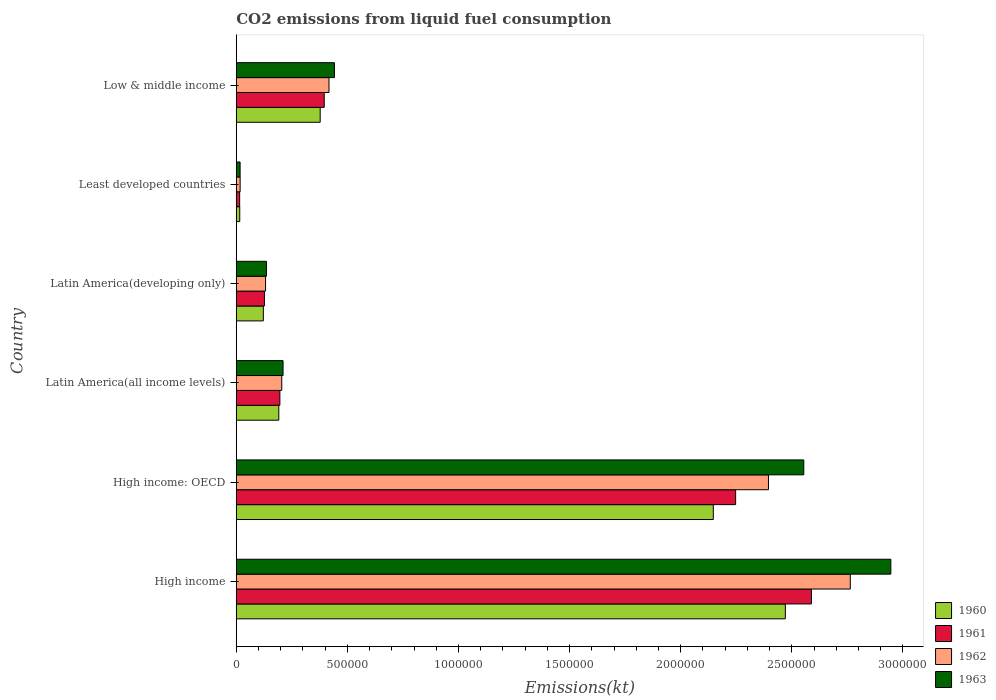How many different coloured bars are there?
Ensure brevity in your answer.  4. Are the number of bars on each tick of the Y-axis equal?
Make the answer very short. Yes. How many bars are there on the 4th tick from the top?
Keep it short and to the point. 4. What is the label of the 3rd group of bars from the top?
Give a very brief answer. Latin America(developing only). What is the amount of CO2 emitted in 1962 in High income?
Your answer should be very brief. 2.76e+06. Across all countries, what is the maximum amount of CO2 emitted in 1963?
Offer a very short reply. 2.95e+06. Across all countries, what is the minimum amount of CO2 emitted in 1960?
Provide a succinct answer. 1.57e+04. In which country was the amount of CO2 emitted in 1961 maximum?
Provide a short and direct response. High income. In which country was the amount of CO2 emitted in 1963 minimum?
Your answer should be very brief. Least developed countries. What is the total amount of CO2 emitted in 1961 in the graph?
Keep it short and to the point. 5.57e+06. What is the difference between the amount of CO2 emitted in 1962 in High income and that in Latin America(all income levels)?
Your answer should be very brief. 2.56e+06. What is the difference between the amount of CO2 emitted in 1962 in Latin America(all income levels) and the amount of CO2 emitted in 1961 in Latin America(developing only)?
Offer a terse response. 7.79e+04. What is the average amount of CO2 emitted in 1960 per country?
Keep it short and to the point. 8.87e+05. What is the difference between the amount of CO2 emitted in 1963 and amount of CO2 emitted in 1960 in Least developed countries?
Offer a terse response. 1527.9. What is the ratio of the amount of CO2 emitted in 1962 in Latin America(all income levels) to that in Least developed countries?
Offer a terse response. 11.72. Is the difference between the amount of CO2 emitted in 1963 in High income: OECD and Low & middle income greater than the difference between the amount of CO2 emitted in 1960 in High income: OECD and Low & middle income?
Provide a succinct answer. Yes. What is the difference between the highest and the second highest amount of CO2 emitted in 1961?
Keep it short and to the point. 3.41e+05. What is the difference between the highest and the lowest amount of CO2 emitted in 1963?
Your answer should be very brief. 2.93e+06. Is the sum of the amount of CO2 emitted in 1960 in High income: OECD and Low & middle income greater than the maximum amount of CO2 emitted in 1962 across all countries?
Ensure brevity in your answer.  No. What does the 1st bar from the bottom in Low & middle income represents?
Give a very brief answer. 1960. How many bars are there?
Keep it short and to the point. 24. Are the values on the major ticks of X-axis written in scientific E-notation?
Offer a very short reply. No. Does the graph contain grids?
Provide a short and direct response. No. Where does the legend appear in the graph?
Make the answer very short. Bottom right. How many legend labels are there?
Your answer should be compact. 4. How are the legend labels stacked?
Offer a very short reply. Vertical. What is the title of the graph?
Keep it short and to the point. CO2 emissions from liquid fuel consumption. What is the label or title of the X-axis?
Make the answer very short. Emissions(kt). What is the Emissions(kt) of 1960 in High income?
Make the answer very short. 2.47e+06. What is the Emissions(kt) of 1961 in High income?
Provide a short and direct response. 2.59e+06. What is the Emissions(kt) in 1962 in High income?
Your response must be concise. 2.76e+06. What is the Emissions(kt) in 1963 in High income?
Your answer should be very brief. 2.95e+06. What is the Emissions(kt) in 1960 in High income: OECD?
Your response must be concise. 2.15e+06. What is the Emissions(kt) of 1961 in High income: OECD?
Give a very brief answer. 2.25e+06. What is the Emissions(kt) of 1962 in High income: OECD?
Offer a very short reply. 2.39e+06. What is the Emissions(kt) in 1963 in High income: OECD?
Make the answer very short. 2.55e+06. What is the Emissions(kt) of 1960 in Latin America(all income levels)?
Ensure brevity in your answer.  1.91e+05. What is the Emissions(kt) in 1961 in Latin America(all income levels)?
Offer a very short reply. 1.96e+05. What is the Emissions(kt) of 1962 in Latin America(all income levels)?
Provide a short and direct response. 2.05e+05. What is the Emissions(kt) of 1963 in Latin America(all income levels)?
Your answer should be very brief. 2.11e+05. What is the Emissions(kt) in 1960 in Latin America(developing only)?
Make the answer very short. 1.22e+05. What is the Emissions(kt) in 1961 in Latin America(developing only)?
Your answer should be compact. 1.27e+05. What is the Emissions(kt) of 1962 in Latin America(developing only)?
Keep it short and to the point. 1.32e+05. What is the Emissions(kt) in 1963 in Latin America(developing only)?
Give a very brief answer. 1.36e+05. What is the Emissions(kt) of 1960 in Least developed countries?
Offer a terse response. 1.57e+04. What is the Emissions(kt) in 1961 in Least developed countries?
Your response must be concise. 1.53e+04. What is the Emissions(kt) in 1962 in Least developed countries?
Provide a short and direct response. 1.75e+04. What is the Emissions(kt) in 1963 in Least developed countries?
Provide a short and direct response. 1.73e+04. What is the Emissions(kt) in 1960 in Low & middle income?
Make the answer very short. 3.78e+05. What is the Emissions(kt) in 1961 in Low & middle income?
Ensure brevity in your answer.  3.96e+05. What is the Emissions(kt) in 1962 in Low & middle income?
Make the answer very short. 4.17e+05. What is the Emissions(kt) of 1963 in Low & middle income?
Provide a short and direct response. 4.42e+05. Across all countries, what is the maximum Emissions(kt) of 1960?
Your answer should be very brief. 2.47e+06. Across all countries, what is the maximum Emissions(kt) in 1961?
Offer a very short reply. 2.59e+06. Across all countries, what is the maximum Emissions(kt) of 1962?
Your response must be concise. 2.76e+06. Across all countries, what is the maximum Emissions(kt) in 1963?
Your answer should be very brief. 2.95e+06. Across all countries, what is the minimum Emissions(kt) of 1960?
Give a very brief answer. 1.57e+04. Across all countries, what is the minimum Emissions(kt) in 1961?
Give a very brief answer. 1.53e+04. Across all countries, what is the minimum Emissions(kt) in 1962?
Provide a succinct answer. 1.75e+04. Across all countries, what is the minimum Emissions(kt) in 1963?
Provide a succinct answer. 1.73e+04. What is the total Emissions(kt) in 1960 in the graph?
Provide a short and direct response. 5.32e+06. What is the total Emissions(kt) of 1961 in the graph?
Your response must be concise. 5.57e+06. What is the total Emissions(kt) of 1962 in the graph?
Keep it short and to the point. 5.93e+06. What is the total Emissions(kt) in 1963 in the graph?
Offer a terse response. 6.30e+06. What is the difference between the Emissions(kt) in 1960 in High income and that in High income: OECD?
Your response must be concise. 3.24e+05. What is the difference between the Emissions(kt) of 1961 in High income and that in High income: OECD?
Provide a succinct answer. 3.41e+05. What is the difference between the Emissions(kt) in 1962 in High income and that in High income: OECD?
Offer a very short reply. 3.68e+05. What is the difference between the Emissions(kt) of 1963 in High income and that in High income: OECD?
Provide a succinct answer. 3.92e+05. What is the difference between the Emissions(kt) in 1960 in High income and that in Latin America(all income levels)?
Provide a short and direct response. 2.28e+06. What is the difference between the Emissions(kt) in 1961 in High income and that in Latin America(all income levels)?
Provide a succinct answer. 2.39e+06. What is the difference between the Emissions(kt) of 1962 in High income and that in Latin America(all income levels)?
Your answer should be compact. 2.56e+06. What is the difference between the Emissions(kt) of 1963 in High income and that in Latin America(all income levels)?
Ensure brevity in your answer.  2.73e+06. What is the difference between the Emissions(kt) of 1960 in High income and that in Latin America(developing only)?
Keep it short and to the point. 2.35e+06. What is the difference between the Emissions(kt) of 1961 in High income and that in Latin America(developing only)?
Offer a very short reply. 2.46e+06. What is the difference between the Emissions(kt) of 1962 in High income and that in Latin America(developing only)?
Give a very brief answer. 2.63e+06. What is the difference between the Emissions(kt) of 1963 in High income and that in Latin America(developing only)?
Give a very brief answer. 2.81e+06. What is the difference between the Emissions(kt) of 1960 in High income and that in Least developed countries?
Keep it short and to the point. 2.46e+06. What is the difference between the Emissions(kt) of 1961 in High income and that in Least developed countries?
Make the answer very short. 2.57e+06. What is the difference between the Emissions(kt) in 1962 in High income and that in Least developed countries?
Offer a very short reply. 2.75e+06. What is the difference between the Emissions(kt) in 1963 in High income and that in Least developed countries?
Give a very brief answer. 2.93e+06. What is the difference between the Emissions(kt) of 1960 in High income and that in Low & middle income?
Provide a short and direct response. 2.09e+06. What is the difference between the Emissions(kt) in 1961 in High income and that in Low & middle income?
Give a very brief answer. 2.19e+06. What is the difference between the Emissions(kt) in 1962 in High income and that in Low & middle income?
Offer a very short reply. 2.35e+06. What is the difference between the Emissions(kt) in 1963 in High income and that in Low & middle income?
Keep it short and to the point. 2.50e+06. What is the difference between the Emissions(kt) in 1960 in High income: OECD and that in Latin America(all income levels)?
Give a very brief answer. 1.96e+06. What is the difference between the Emissions(kt) in 1961 in High income: OECD and that in Latin America(all income levels)?
Keep it short and to the point. 2.05e+06. What is the difference between the Emissions(kt) of 1962 in High income: OECD and that in Latin America(all income levels)?
Your answer should be compact. 2.19e+06. What is the difference between the Emissions(kt) in 1963 in High income: OECD and that in Latin America(all income levels)?
Your answer should be very brief. 2.34e+06. What is the difference between the Emissions(kt) in 1960 in High income: OECD and that in Latin America(developing only)?
Your answer should be very brief. 2.02e+06. What is the difference between the Emissions(kt) of 1961 in High income: OECD and that in Latin America(developing only)?
Keep it short and to the point. 2.12e+06. What is the difference between the Emissions(kt) in 1962 in High income: OECD and that in Latin America(developing only)?
Offer a very short reply. 2.26e+06. What is the difference between the Emissions(kt) in 1963 in High income: OECD and that in Latin America(developing only)?
Your answer should be compact. 2.42e+06. What is the difference between the Emissions(kt) of 1960 in High income: OECD and that in Least developed countries?
Your response must be concise. 2.13e+06. What is the difference between the Emissions(kt) of 1961 in High income: OECD and that in Least developed countries?
Your answer should be very brief. 2.23e+06. What is the difference between the Emissions(kt) in 1962 in High income: OECD and that in Least developed countries?
Ensure brevity in your answer.  2.38e+06. What is the difference between the Emissions(kt) of 1963 in High income: OECD and that in Least developed countries?
Your answer should be compact. 2.54e+06. What is the difference between the Emissions(kt) of 1960 in High income: OECD and that in Low & middle income?
Your response must be concise. 1.77e+06. What is the difference between the Emissions(kt) in 1961 in High income: OECD and that in Low & middle income?
Ensure brevity in your answer.  1.85e+06. What is the difference between the Emissions(kt) in 1962 in High income: OECD and that in Low & middle income?
Your response must be concise. 1.98e+06. What is the difference between the Emissions(kt) of 1963 in High income: OECD and that in Low & middle income?
Ensure brevity in your answer.  2.11e+06. What is the difference between the Emissions(kt) of 1960 in Latin America(all income levels) and that in Latin America(developing only)?
Provide a short and direct response. 6.96e+04. What is the difference between the Emissions(kt) of 1961 in Latin America(all income levels) and that in Latin America(developing only)?
Provide a succinct answer. 6.94e+04. What is the difference between the Emissions(kt) in 1962 in Latin America(all income levels) and that in Latin America(developing only)?
Give a very brief answer. 7.28e+04. What is the difference between the Emissions(kt) in 1963 in Latin America(all income levels) and that in Latin America(developing only)?
Your answer should be compact. 7.46e+04. What is the difference between the Emissions(kt) in 1960 in Latin America(all income levels) and that in Least developed countries?
Ensure brevity in your answer.  1.76e+05. What is the difference between the Emissions(kt) in 1961 in Latin America(all income levels) and that in Least developed countries?
Give a very brief answer. 1.81e+05. What is the difference between the Emissions(kt) in 1962 in Latin America(all income levels) and that in Least developed countries?
Provide a succinct answer. 1.87e+05. What is the difference between the Emissions(kt) in 1963 in Latin America(all income levels) and that in Least developed countries?
Keep it short and to the point. 1.93e+05. What is the difference between the Emissions(kt) in 1960 in Latin America(all income levels) and that in Low & middle income?
Your response must be concise. -1.86e+05. What is the difference between the Emissions(kt) in 1961 in Latin America(all income levels) and that in Low & middle income?
Your answer should be compact. -2.00e+05. What is the difference between the Emissions(kt) of 1962 in Latin America(all income levels) and that in Low & middle income?
Provide a succinct answer. -2.13e+05. What is the difference between the Emissions(kt) of 1963 in Latin America(all income levels) and that in Low & middle income?
Offer a terse response. -2.31e+05. What is the difference between the Emissions(kt) in 1960 in Latin America(developing only) and that in Least developed countries?
Make the answer very short. 1.06e+05. What is the difference between the Emissions(kt) in 1961 in Latin America(developing only) and that in Least developed countries?
Make the answer very short. 1.11e+05. What is the difference between the Emissions(kt) of 1962 in Latin America(developing only) and that in Least developed countries?
Your response must be concise. 1.14e+05. What is the difference between the Emissions(kt) in 1963 in Latin America(developing only) and that in Least developed countries?
Your answer should be very brief. 1.19e+05. What is the difference between the Emissions(kt) of 1960 in Latin America(developing only) and that in Low & middle income?
Keep it short and to the point. -2.56e+05. What is the difference between the Emissions(kt) in 1961 in Latin America(developing only) and that in Low & middle income?
Give a very brief answer. -2.69e+05. What is the difference between the Emissions(kt) of 1962 in Latin America(developing only) and that in Low & middle income?
Give a very brief answer. -2.85e+05. What is the difference between the Emissions(kt) in 1963 in Latin America(developing only) and that in Low & middle income?
Ensure brevity in your answer.  -3.06e+05. What is the difference between the Emissions(kt) in 1960 in Least developed countries and that in Low & middle income?
Keep it short and to the point. -3.62e+05. What is the difference between the Emissions(kt) of 1961 in Least developed countries and that in Low & middle income?
Keep it short and to the point. -3.81e+05. What is the difference between the Emissions(kt) in 1962 in Least developed countries and that in Low & middle income?
Your response must be concise. -4.00e+05. What is the difference between the Emissions(kt) in 1963 in Least developed countries and that in Low & middle income?
Provide a short and direct response. -4.25e+05. What is the difference between the Emissions(kt) in 1960 in High income and the Emissions(kt) in 1961 in High income: OECD?
Offer a very short reply. 2.24e+05. What is the difference between the Emissions(kt) in 1960 in High income and the Emissions(kt) in 1962 in High income: OECD?
Give a very brief answer. 7.59e+04. What is the difference between the Emissions(kt) of 1960 in High income and the Emissions(kt) of 1963 in High income: OECD?
Ensure brevity in your answer.  -8.29e+04. What is the difference between the Emissions(kt) of 1961 in High income and the Emissions(kt) of 1962 in High income: OECD?
Your answer should be very brief. 1.93e+05. What is the difference between the Emissions(kt) in 1961 in High income and the Emissions(kt) in 1963 in High income: OECD?
Make the answer very short. 3.45e+04. What is the difference between the Emissions(kt) of 1962 in High income and the Emissions(kt) of 1963 in High income: OECD?
Give a very brief answer. 2.09e+05. What is the difference between the Emissions(kt) of 1960 in High income and the Emissions(kt) of 1961 in Latin America(all income levels)?
Make the answer very short. 2.27e+06. What is the difference between the Emissions(kt) in 1960 in High income and the Emissions(kt) in 1962 in Latin America(all income levels)?
Provide a succinct answer. 2.27e+06. What is the difference between the Emissions(kt) in 1960 in High income and the Emissions(kt) in 1963 in Latin America(all income levels)?
Offer a terse response. 2.26e+06. What is the difference between the Emissions(kt) of 1961 in High income and the Emissions(kt) of 1962 in Latin America(all income levels)?
Your answer should be compact. 2.38e+06. What is the difference between the Emissions(kt) of 1961 in High income and the Emissions(kt) of 1963 in Latin America(all income levels)?
Your answer should be compact. 2.38e+06. What is the difference between the Emissions(kt) of 1962 in High income and the Emissions(kt) of 1963 in Latin America(all income levels)?
Give a very brief answer. 2.55e+06. What is the difference between the Emissions(kt) in 1960 in High income and the Emissions(kt) in 1961 in Latin America(developing only)?
Ensure brevity in your answer.  2.34e+06. What is the difference between the Emissions(kt) in 1960 in High income and the Emissions(kt) in 1962 in Latin America(developing only)?
Ensure brevity in your answer.  2.34e+06. What is the difference between the Emissions(kt) in 1960 in High income and the Emissions(kt) in 1963 in Latin America(developing only)?
Your answer should be very brief. 2.33e+06. What is the difference between the Emissions(kt) in 1961 in High income and the Emissions(kt) in 1962 in Latin America(developing only)?
Ensure brevity in your answer.  2.46e+06. What is the difference between the Emissions(kt) in 1961 in High income and the Emissions(kt) in 1963 in Latin America(developing only)?
Offer a terse response. 2.45e+06. What is the difference between the Emissions(kt) of 1962 in High income and the Emissions(kt) of 1963 in Latin America(developing only)?
Give a very brief answer. 2.63e+06. What is the difference between the Emissions(kt) in 1960 in High income and the Emissions(kt) in 1961 in Least developed countries?
Provide a short and direct response. 2.46e+06. What is the difference between the Emissions(kt) of 1960 in High income and the Emissions(kt) of 1962 in Least developed countries?
Your response must be concise. 2.45e+06. What is the difference between the Emissions(kt) of 1960 in High income and the Emissions(kt) of 1963 in Least developed countries?
Provide a succinct answer. 2.45e+06. What is the difference between the Emissions(kt) of 1961 in High income and the Emissions(kt) of 1962 in Least developed countries?
Ensure brevity in your answer.  2.57e+06. What is the difference between the Emissions(kt) in 1961 in High income and the Emissions(kt) in 1963 in Least developed countries?
Your answer should be very brief. 2.57e+06. What is the difference between the Emissions(kt) in 1962 in High income and the Emissions(kt) in 1963 in Least developed countries?
Give a very brief answer. 2.75e+06. What is the difference between the Emissions(kt) of 1960 in High income and the Emissions(kt) of 1961 in Low & middle income?
Offer a very short reply. 2.07e+06. What is the difference between the Emissions(kt) in 1960 in High income and the Emissions(kt) in 1962 in Low & middle income?
Your answer should be very brief. 2.05e+06. What is the difference between the Emissions(kt) of 1960 in High income and the Emissions(kt) of 1963 in Low & middle income?
Your answer should be very brief. 2.03e+06. What is the difference between the Emissions(kt) of 1961 in High income and the Emissions(kt) of 1962 in Low & middle income?
Keep it short and to the point. 2.17e+06. What is the difference between the Emissions(kt) in 1961 in High income and the Emissions(kt) in 1963 in Low & middle income?
Provide a succinct answer. 2.15e+06. What is the difference between the Emissions(kt) of 1962 in High income and the Emissions(kt) of 1963 in Low & middle income?
Your answer should be compact. 2.32e+06. What is the difference between the Emissions(kt) in 1960 in High income: OECD and the Emissions(kt) in 1961 in Latin America(all income levels)?
Provide a short and direct response. 1.95e+06. What is the difference between the Emissions(kt) in 1960 in High income: OECD and the Emissions(kt) in 1962 in Latin America(all income levels)?
Your answer should be compact. 1.94e+06. What is the difference between the Emissions(kt) of 1960 in High income: OECD and the Emissions(kt) of 1963 in Latin America(all income levels)?
Ensure brevity in your answer.  1.94e+06. What is the difference between the Emissions(kt) of 1961 in High income: OECD and the Emissions(kt) of 1962 in Latin America(all income levels)?
Your response must be concise. 2.04e+06. What is the difference between the Emissions(kt) of 1961 in High income: OECD and the Emissions(kt) of 1963 in Latin America(all income levels)?
Offer a terse response. 2.04e+06. What is the difference between the Emissions(kt) in 1962 in High income: OECD and the Emissions(kt) in 1963 in Latin America(all income levels)?
Offer a terse response. 2.18e+06. What is the difference between the Emissions(kt) in 1960 in High income: OECD and the Emissions(kt) in 1961 in Latin America(developing only)?
Your answer should be compact. 2.02e+06. What is the difference between the Emissions(kt) in 1960 in High income: OECD and the Emissions(kt) in 1962 in Latin America(developing only)?
Provide a succinct answer. 2.01e+06. What is the difference between the Emissions(kt) of 1960 in High income: OECD and the Emissions(kt) of 1963 in Latin America(developing only)?
Ensure brevity in your answer.  2.01e+06. What is the difference between the Emissions(kt) in 1961 in High income: OECD and the Emissions(kt) in 1962 in Latin America(developing only)?
Provide a short and direct response. 2.12e+06. What is the difference between the Emissions(kt) of 1961 in High income: OECD and the Emissions(kt) of 1963 in Latin America(developing only)?
Make the answer very short. 2.11e+06. What is the difference between the Emissions(kt) in 1962 in High income: OECD and the Emissions(kt) in 1963 in Latin America(developing only)?
Provide a succinct answer. 2.26e+06. What is the difference between the Emissions(kt) of 1960 in High income: OECD and the Emissions(kt) of 1961 in Least developed countries?
Offer a very short reply. 2.13e+06. What is the difference between the Emissions(kt) of 1960 in High income: OECD and the Emissions(kt) of 1962 in Least developed countries?
Provide a short and direct response. 2.13e+06. What is the difference between the Emissions(kt) in 1960 in High income: OECD and the Emissions(kt) in 1963 in Least developed countries?
Offer a terse response. 2.13e+06. What is the difference between the Emissions(kt) of 1961 in High income: OECD and the Emissions(kt) of 1962 in Least developed countries?
Offer a terse response. 2.23e+06. What is the difference between the Emissions(kt) in 1961 in High income: OECD and the Emissions(kt) in 1963 in Least developed countries?
Your response must be concise. 2.23e+06. What is the difference between the Emissions(kt) in 1962 in High income: OECD and the Emissions(kt) in 1963 in Least developed countries?
Provide a short and direct response. 2.38e+06. What is the difference between the Emissions(kt) of 1960 in High income: OECD and the Emissions(kt) of 1961 in Low & middle income?
Provide a short and direct response. 1.75e+06. What is the difference between the Emissions(kt) of 1960 in High income: OECD and the Emissions(kt) of 1962 in Low & middle income?
Provide a short and direct response. 1.73e+06. What is the difference between the Emissions(kt) in 1960 in High income: OECD and the Emissions(kt) in 1963 in Low & middle income?
Provide a succinct answer. 1.70e+06. What is the difference between the Emissions(kt) of 1961 in High income: OECD and the Emissions(kt) of 1962 in Low & middle income?
Keep it short and to the point. 1.83e+06. What is the difference between the Emissions(kt) of 1961 in High income: OECD and the Emissions(kt) of 1963 in Low & middle income?
Keep it short and to the point. 1.81e+06. What is the difference between the Emissions(kt) of 1962 in High income: OECD and the Emissions(kt) of 1963 in Low & middle income?
Offer a very short reply. 1.95e+06. What is the difference between the Emissions(kt) in 1960 in Latin America(all income levels) and the Emissions(kt) in 1961 in Latin America(developing only)?
Give a very brief answer. 6.46e+04. What is the difference between the Emissions(kt) in 1960 in Latin America(all income levels) and the Emissions(kt) in 1962 in Latin America(developing only)?
Provide a short and direct response. 5.96e+04. What is the difference between the Emissions(kt) in 1960 in Latin America(all income levels) and the Emissions(kt) in 1963 in Latin America(developing only)?
Keep it short and to the point. 5.55e+04. What is the difference between the Emissions(kt) of 1961 in Latin America(all income levels) and the Emissions(kt) of 1962 in Latin America(developing only)?
Give a very brief answer. 6.44e+04. What is the difference between the Emissions(kt) of 1961 in Latin America(all income levels) and the Emissions(kt) of 1963 in Latin America(developing only)?
Offer a terse response. 6.03e+04. What is the difference between the Emissions(kt) in 1962 in Latin America(all income levels) and the Emissions(kt) in 1963 in Latin America(developing only)?
Your response must be concise. 6.88e+04. What is the difference between the Emissions(kt) of 1960 in Latin America(all income levels) and the Emissions(kt) of 1961 in Least developed countries?
Your response must be concise. 1.76e+05. What is the difference between the Emissions(kt) of 1960 in Latin America(all income levels) and the Emissions(kt) of 1962 in Least developed countries?
Your response must be concise. 1.74e+05. What is the difference between the Emissions(kt) in 1960 in Latin America(all income levels) and the Emissions(kt) in 1963 in Least developed countries?
Provide a succinct answer. 1.74e+05. What is the difference between the Emissions(kt) in 1961 in Latin America(all income levels) and the Emissions(kt) in 1962 in Least developed countries?
Offer a very short reply. 1.79e+05. What is the difference between the Emissions(kt) of 1961 in Latin America(all income levels) and the Emissions(kt) of 1963 in Least developed countries?
Make the answer very short. 1.79e+05. What is the difference between the Emissions(kt) in 1962 in Latin America(all income levels) and the Emissions(kt) in 1963 in Least developed countries?
Your answer should be very brief. 1.87e+05. What is the difference between the Emissions(kt) in 1960 in Latin America(all income levels) and the Emissions(kt) in 1961 in Low & middle income?
Offer a terse response. -2.04e+05. What is the difference between the Emissions(kt) in 1960 in Latin America(all income levels) and the Emissions(kt) in 1962 in Low & middle income?
Your answer should be compact. -2.26e+05. What is the difference between the Emissions(kt) in 1960 in Latin America(all income levels) and the Emissions(kt) in 1963 in Low & middle income?
Your response must be concise. -2.50e+05. What is the difference between the Emissions(kt) of 1961 in Latin America(all income levels) and the Emissions(kt) of 1962 in Low & middle income?
Your answer should be very brief. -2.21e+05. What is the difference between the Emissions(kt) in 1961 in Latin America(all income levels) and the Emissions(kt) in 1963 in Low & middle income?
Keep it short and to the point. -2.46e+05. What is the difference between the Emissions(kt) in 1962 in Latin America(all income levels) and the Emissions(kt) in 1963 in Low & middle income?
Your answer should be compact. -2.37e+05. What is the difference between the Emissions(kt) of 1960 in Latin America(developing only) and the Emissions(kt) of 1961 in Least developed countries?
Provide a short and direct response. 1.07e+05. What is the difference between the Emissions(kt) in 1960 in Latin America(developing only) and the Emissions(kt) in 1962 in Least developed countries?
Offer a very short reply. 1.04e+05. What is the difference between the Emissions(kt) of 1960 in Latin America(developing only) and the Emissions(kt) of 1963 in Least developed countries?
Offer a terse response. 1.05e+05. What is the difference between the Emissions(kt) of 1961 in Latin America(developing only) and the Emissions(kt) of 1962 in Least developed countries?
Keep it short and to the point. 1.09e+05. What is the difference between the Emissions(kt) in 1961 in Latin America(developing only) and the Emissions(kt) in 1963 in Least developed countries?
Make the answer very short. 1.10e+05. What is the difference between the Emissions(kt) in 1962 in Latin America(developing only) and the Emissions(kt) in 1963 in Least developed countries?
Your answer should be compact. 1.15e+05. What is the difference between the Emissions(kt) in 1960 in Latin America(developing only) and the Emissions(kt) in 1961 in Low & middle income?
Provide a succinct answer. -2.74e+05. What is the difference between the Emissions(kt) in 1960 in Latin America(developing only) and the Emissions(kt) in 1962 in Low & middle income?
Offer a terse response. -2.95e+05. What is the difference between the Emissions(kt) in 1960 in Latin America(developing only) and the Emissions(kt) in 1963 in Low & middle income?
Offer a very short reply. -3.20e+05. What is the difference between the Emissions(kt) in 1961 in Latin America(developing only) and the Emissions(kt) in 1962 in Low & middle income?
Give a very brief answer. -2.90e+05. What is the difference between the Emissions(kt) of 1961 in Latin America(developing only) and the Emissions(kt) of 1963 in Low & middle income?
Make the answer very short. -3.15e+05. What is the difference between the Emissions(kt) in 1962 in Latin America(developing only) and the Emissions(kt) in 1963 in Low & middle income?
Your answer should be very brief. -3.10e+05. What is the difference between the Emissions(kt) in 1960 in Least developed countries and the Emissions(kt) in 1961 in Low & middle income?
Your answer should be compact. -3.80e+05. What is the difference between the Emissions(kt) of 1960 in Least developed countries and the Emissions(kt) of 1962 in Low & middle income?
Your answer should be compact. -4.02e+05. What is the difference between the Emissions(kt) in 1960 in Least developed countries and the Emissions(kt) in 1963 in Low & middle income?
Ensure brevity in your answer.  -4.26e+05. What is the difference between the Emissions(kt) of 1961 in Least developed countries and the Emissions(kt) of 1962 in Low & middle income?
Ensure brevity in your answer.  -4.02e+05. What is the difference between the Emissions(kt) of 1961 in Least developed countries and the Emissions(kt) of 1963 in Low & middle income?
Your answer should be compact. -4.27e+05. What is the difference between the Emissions(kt) of 1962 in Least developed countries and the Emissions(kt) of 1963 in Low & middle income?
Make the answer very short. -4.24e+05. What is the average Emissions(kt) of 1960 per country?
Your answer should be very brief. 8.87e+05. What is the average Emissions(kt) in 1961 per country?
Ensure brevity in your answer.  9.28e+05. What is the average Emissions(kt) of 1962 per country?
Your answer should be very brief. 9.88e+05. What is the average Emissions(kt) in 1963 per country?
Give a very brief answer. 1.05e+06. What is the difference between the Emissions(kt) in 1960 and Emissions(kt) in 1961 in High income?
Your answer should be very brief. -1.17e+05. What is the difference between the Emissions(kt) in 1960 and Emissions(kt) in 1962 in High income?
Your answer should be very brief. -2.92e+05. What is the difference between the Emissions(kt) in 1960 and Emissions(kt) in 1963 in High income?
Keep it short and to the point. -4.75e+05. What is the difference between the Emissions(kt) in 1961 and Emissions(kt) in 1962 in High income?
Keep it short and to the point. -1.75e+05. What is the difference between the Emissions(kt) of 1961 and Emissions(kt) of 1963 in High income?
Your answer should be compact. -3.57e+05. What is the difference between the Emissions(kt) of 1962 and Emissions(kt) of 1963 in High income?
Make the answer very short. -1.82e+05. What is the difference between the Emissions(kt) of 1960 and Emissions(kt) of 1961 in High income: OECD?
Provide a short and direct response. -1.01e+05. What is the difference between the Emissions(kt) of 1960 and Emissions(kt) of 1962 in High income: OECD?
Offer a terse response. -2.48e+05. What is the difference between the Emissions(kt) of 1960 and Emissions(kt) of 1963 in High income: OECD?
Make the answer very short. -4.07e+05. What is the difference between the Emissions(kt) of 1961 and Emissions(kt) of 1962 in High income: OECD?
Your answer should be very brief. -1.48e+05. What is the difference between the Emissions(kt) of 1961 and Emissions(kt) of 1963 in High income: OECD?
Make the answer very short. -3.07e+05. What is the difference between the Emissions(kt) of 1962 and Emissions(kt) of 1963 in High income: OECD?
Provide a short and direct response. -1.59e+05. What is the difference between the Emissions(kt) in 1960 and Emissions(kt) in 1961 in Latin America(all income levels)?
Ensure brevity in your answer.  -4804.69. What is the difference between the Emissions(kt) of 1960 and Emissions(kt) of 1962 in Latin America(all income levels)?
Your answer should be very brief. -1.33e+04. What is the difference between the Emissions(kt) in 1960 and Emissions(kt) in 1963 in Latin America(all income levels)?
Your answer should be compact. -1.91e+04. What is the difference between the Emissions(kt) in 1961 and Emissions(kt) in 1962 in Latin America(all income levels)?
Make the answer very short. -8448.73. What is the difference between the Emissions(kt) in 1961 and Emissions(kt) in 1963 in Latin America(all income levels)?
Offer a very short reply. -1.43e+04. What is the difference between the Emissions(kt) in 1962 and Emissions(kt) in 1963 in Latin America(all income levels)?
Make the answer very short. -5855.18. What is the difference between the Emissions(kt) of 1960 and Emissions(kt) of 1961 in Latin America(developing only)?
Keep it short and to the point. -4921.11. What is the difference between the Emissions(kt) of 1960 and Emissions(kt) of 1962 in Latin America(developing only)?
Your answer should be very brief. -9981.57. What is the difference between the Emissions(kt) in 1960 and Emissions(kt) in 1963 in Latin America(developing only)?
Ensure brevity in your answer.  -1.40e+04. What is the difference between the Emissions(kt) of 1961 and Emissions(kt) of 1962 in Latin America(developing only)?
Provide a short and direct response. -5060.46. What is the difference between the Emissions(kt) of 1961 and Emissions(kt) of 1963 in Latin America(developing only)?
Make the answer very short. -9119.83. What is the difference between the Emissions(kt) in 1962 and Emissions(kt) in 1963 in Latin America(developing only)?
Keep it short and to the point. -4059.37. What is the difference between the Emissions(kt) of 1960 and Emissions(kt) of 1961 in Least developed countries?
Your answer should be compact. 407.2. What is the difference between the Emissions(kt) of 1960 and Emissions(kt) of 1962 in Least developed countries?
Provide a short and direct response. -1724.44. What is the difference between the Emissions(kt) of 1960 and Emissions(kt) of 1963 in Least developed countries?
Provide a short and direct response. -1527.9. What is the difference between the Emissions(kt) in 1961 and Emissions(kt) in 1962 in Least developed countries?
Your answer should be very brief. -2131.64. What is the difference between the Emissions(kt) of 1961 and Emissions(kt) of 1963 in Least developed countries?
Make the answer very short. -1935.1. What is the difference between the Emissions(kt) of 1962 and Emissions(kt) of 1963 in Least developed countries?
Ensure brevity in your answer.  196.54. What is the difference between the Emissions(kt) of 1960 and Emissions(kt) of 1961 in Low & middle income?
Make the answer very short. -1.83e+04. What is the difference between the Emissions(kt) in 1960 and Emissions(kt) in 1962 in Low & middle income?
Provide a succinct answer. -3.96e+04. What is the difference between the Emissions(kt) of 1960 and Emissions(kt) of 1963 in Low & middle income?
Make the answer very short. -6.42e+04. What is the difference between the Emissions(kt) in 1961 and Emissions(kt) in 1962 in Low & middle income?
Your response must be concise. -2.14e+04. What is the difference between the Emissions(kt) of 1961 and Emissions(kt) of 1963 in Low & middle income?
Provide a succinct answer. -4.59e+04. What is the difference between the Emissions(kt) in 1962 and Emissions(kt) in 1963 in Low & middle income?
Your answer should be very brief. -2.46e+04. What is the ratio of the Emissions(kt) in 1960 in High income to that in High income: OECD?
Your answer should be compact. 1.15. What is the ratio of the Emissions(kt) of 1961 in High income to that in High income: OECD?
Your response must be concise. 1.15. What is the ratio of the Emissions(kt) of 1962 in High income to that in High income: OECD?
Offer a very short reply. 1.15. What is the ratio of the Emissions(kt) of 1963 in High income to that in High income: OECD?
Provide a succinct answer. 1.15. What is the ratio of the Emissions(kt) of 1960 in High income to that in Latin America(all income levels)?
Your answer should be compact. 12.91. What is the ratio of the Emissions(kt) of 1961 in High income to that in Latin America(all income levels)?
Provide a succinct answer. 13.19. What is the ratio of the Emissions(kt) of 1962 in High income to that in Latin America(all income levels)?
Offer a terse response. 13.5. What is the ratio of the Emissions(kt) in 1963 in High income to that in Latin America(all income levels)?
Make the answer very short. 13.99. What is the ratio of the Emissions(kt) of 1960 in High income to that in Latin America(developing only)?
Provide a short and direct response. 20.27. What is the ratio of the Emissions(kt) of 1961 in High income to that in Latin America(developing only)?
Give a very brief answer. 20.41. What is the ratio of the Emissions(kt) of 1962 in High income to that in Latin America(developing only)?
Provide a short and direct response. 20.95. What is the ratio of the Emissions(kt) of 1963 in High income to that in Latin America(developing only)?
Make the answer very short. 21.67. What is the ratio of the Emissions(kt) of 1960 in High income to that in Least developed countries?
Provide a succinct answer. 156.98. What is the ratio of the Emissions(kt) in 1961 in High income to that in Least developed countries?
Your response must be concise. 168.8. What is the ratio of the Emissions(kt) of 1962 in High income to that in Least developed countries?
Provide a succinct answer. 158.21. What is the ratio of the Emissions(kt) in 1963 in High income to that in Least developed countries?
Provide a short and direct response. 170.58. What is the ratio of the Emissions(kt) in 1960 in High income to that in Low & middle income?
Your response must be concise. 6.54. What is the ratio of the Emissions(kt) in 1961 in High income to that in Low & middle income?
Offer a terse response. 6.54. What is the ratio of the Emissions(kt) in 1962 in High income to that in Low & middle income?
Your answer should be very brief. 6.62. What is the ratio of the Emissions(kt) of 1963 in High income to that in Low & middle income?
Ensure brevity in your answer.  6.67. What is the ratio of the Emissions(kt) in 1960 in High income: OECD to that in Latin America(all income levels)?
Offer a terse response. 11.21. What is the ratio of the Emissions(kt) in 1961 in High income: OECD to that in Latin America(all income levels)?
Ensure brevity in your answer.  11.45. What is the ratio of the Emissions(kt) of 1962 in High income: OECD to that in Latin America(all income levels)?
Ensure brevity in your answer.  11.7. What is the ratio of the Emissions(kt) of 1963 in High income: OECD to that in Latin America(all income levels)?
Offer a terse response. 12.13. What is the ratio of the Emissions(kt) in 1960 in High income: OECD to that in Latin America(developing only)?
Your response must be concise. 17.61. What is the ratio of the Emissions(kt) in 1961 in High income: OECD to that in Latin America(developing only)?
Offer a very short reply. 17.72. What is the ratio of the Emissions(kt) in 1962 in High income: OECD to that in Latin America(developing only)?
Provide a short and direct response. 18.16. What is the ratio of the Emissions(kt) in 1963 in High income: OECD to that in Latin America(developing only)?
Your answer should be very brief. 18.79. What is the ratio of the Emissions(kt) of 1960 in High income: OECD to that in Least developed countries?
Your answer should be very brief. 136.38. What is the ratio of the Emissions(kt) in 1961 in High income: OECD to that in Least developed countries?
Your answer should be very brief. 146.56. What is the ratio of the Emissions(kt) in 1962 in High income: OECD to that in Least developed countries?
Your answer should be very brief. 137.13. What is the ratio of the Emissions(kt) in 1963 in High income: OECD to that in Least developed countries?
Offer a terse response. 147.89. What is the ratio of the Emissions(kt) of 1960 in High income: OECD to that in Low & middle income?
Ensure brevity in your answer.  5.68. What is the ratio of the Emissions(kt) of 1961 in High income: OECD to that in Low & middle income?
Your answer should be very brief. 5.68. What is the ratio of the Emissions(kt) of 1962 in High income: OECD to that in Low & middle income?
Your answer should be compact. 5.74. What is the ratio of the Emissions(kt) in 1963 in High income: OECD to that in Low & middle income?
Your response must be concise. 5.78. What is the ratio of the Emissions(kt) in 1960 in Latin America(all income levels) to that in Latin America(developing only)?
Ensure brevity in your answer.  1.57. What is the ratio of the Emissions(kt) in 1961 in Latin America(all income levels) to that in Latin America(developing only)?
Your answer should be compact. 1.55. What is the ratio of the Emissions(kt) in 1962 in Latin America(all income levels) to that in Latin America(developing only)?
Ensure brevity in your answer.  1.55. What is the ratio of the Emissions(kt) of 1963 in Latin America(all income levels) to that in Latin America(developing only)?
Give a very brief answer. 1.55. What is the ratio of the Emissions(kt) in 1960 in Latin America(all income levels) to that in Least developed countries?
Give a very brief answer. 12.16. What is the ratio of the Emissions(kt) of 1961 in Latin America(all income levels) to that in Least developed countries?
Give a very brief answer. 12.8. What is the ratio of the Emissions(kt) of 1962 in Latin America(all income levels) to that in Least developed countries?
Your answer should be compact. 11.72. What is the ratio of the Emissions(kt) in 1963 in Latin America(all income levels) to that in Least developed countries?
Your response must be concise. 12.19. What is the ratio of the Emissions(kt) in 1960 in Latin America(all income levels) to that in Low & middle income?
Offer a terse response. 0.51. What is the ratio of the Emissions(kt) of 1961 in Latin America(all income levels) to that in Low & middle income?
Give a very brief answer. 0.5. What is the ratio of the Emissions(kt) of 1962 in Latin America(all income levels) to that in Low & middle income?
Make the answer very short. 0.49. What is the ratio of the Emissions(kt) of 1963 in Latin America(all income levels) to that in Low & middle income?
Your answer should be compact. 0.48. What is the ratio of the Emissions(kt) in 1960 in Latin America(developing only) to that in Least developed countries?
Your answer should be very brief. 7.74. What is the ratio of the Emissions(kt) of 1961 in Latin America(developing only) to that in Least developed countries?
Provide a succinct answer. 8.27. What is the ratio of the Emissions(kt) in 1962 in Latin America(developing only) to that in Least developed countries?
Give a very brief answer. 7.55. What is the ratio of the Emissions(kt) in 1963 in Latin America(developing only) to that in Least developed countries?
Keep it short and to the point. 7.87. What is the ratio of the Emissions(kt) of 1960 in Latin America(developing only) to that in Low & middle income?
Provide a short and direct response. 0.32. What is the ratio of the Emissions(kt) in 1961 in Latin America(developing only) to that in Low & middle income?
Offer a very short reply. 0.32. What is the ratio of the Emissions(kt) in 1962 in Latin America(developing only) to that in Low & middle income?
Make the answer very short. 0.32. What is the ratio of the Emissions(kt) of 1963 in Latin America(developing only) to that in Low & middle income?
Your answer should be compact. 0.31. What is the ratio of the Emissions(kt) in 1960 in Least developed countries to that in Low & middle income?
Offer a terse response. 0.04. What is the ratio of the Emissions(kt) of 1961 in Least developed countries to that in Low & middle income?
Provide a succinct answer. 0.04. What is the ratio of the Emissions(kt) of 1962 in Least developed countries to that in Low & middle income?
Make the answer very short. 0.04. What is the ratio of the Emissions(kt) in 1963 in Least developed countries to that in Low & middle income?
Offer a terse response. 0.04. What is the difference between the highest and the second highest Emissions(kt) in 1960?
Ensure brevity in your answer.  3.24e+05. What is the difference between the highest and the second highest Emissions(kt) in 1961?
Make the answer very short. 3.41e+05. What is the difference between the highest and the second highest Emissions(kt) in 1962?
Offer a terse response. 3.68e+05. What is the difference between the highest and the second highest Emissions(kt) of 1963?
Your response must be concise. 3.92e+05. What is the difference between the highest and the lowest Emissions(kt) in 1960?
Offer a terse response. 2.46e+06. What is the difference between the highest and the lowest Emissions(kt) of 1961?
Ensure brevity in your answer.  2.57e+06. What is the difference between the highest and the lowest Emissions(kt) in 1962?
Make the answer very short. 2.75e+06. What is the difference between the highest and the lowest Emissions(kt) in 1963?
Keep it short and to the point. 2.93e+06. 